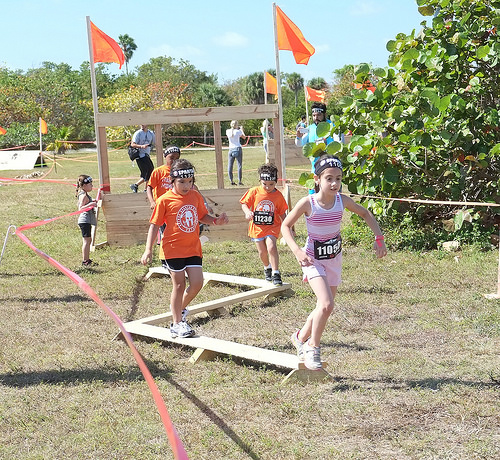<image>
Is the flag behind the girl? Yes. From this viewpoint, the flag is positioned behind the girl, with the girl partially or fully occluding the flag. Is the flag in front of the girl? No. The flag is not in front of the girl. The spatial positioning shows a different relationship between these objects. 